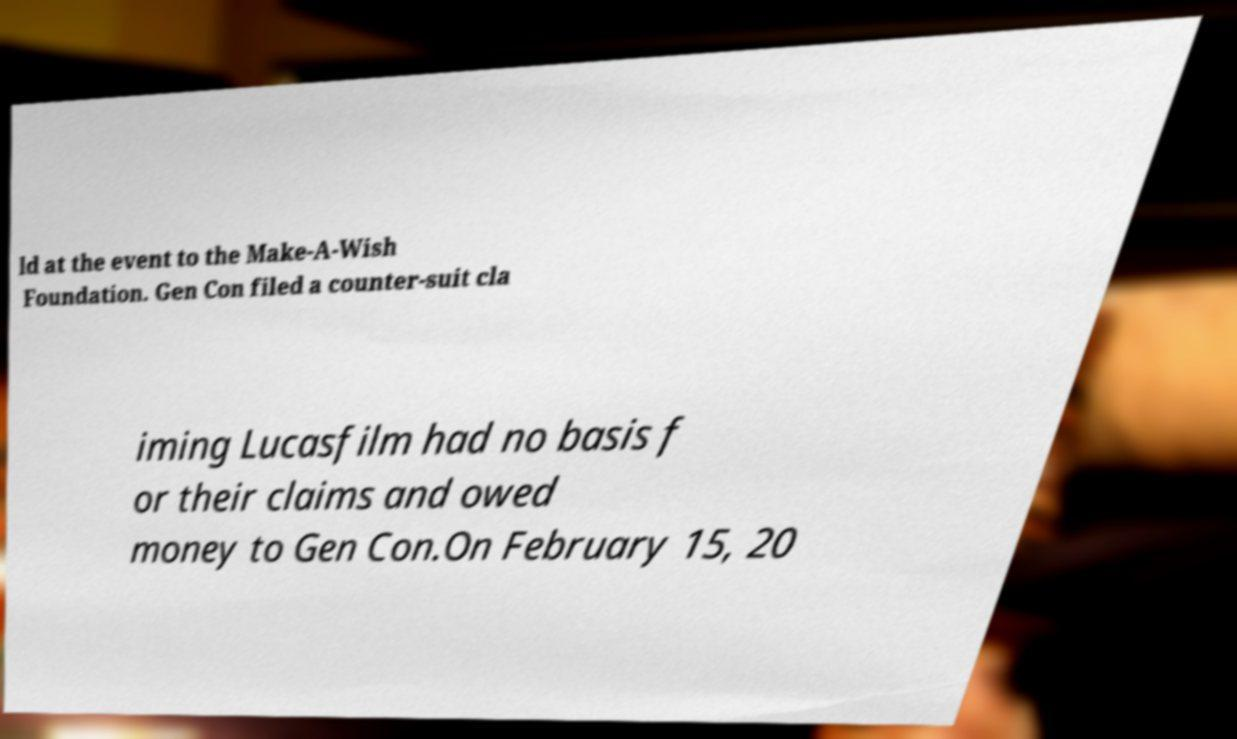Please identify and transcribe the text found in this image. ld at the event to the Make-A-Wish Foundation. Gen Con filed a counter-suit cla iming Lucasfilm had no basis f or their claims and owed money to Gen Con.On February 15, 20 